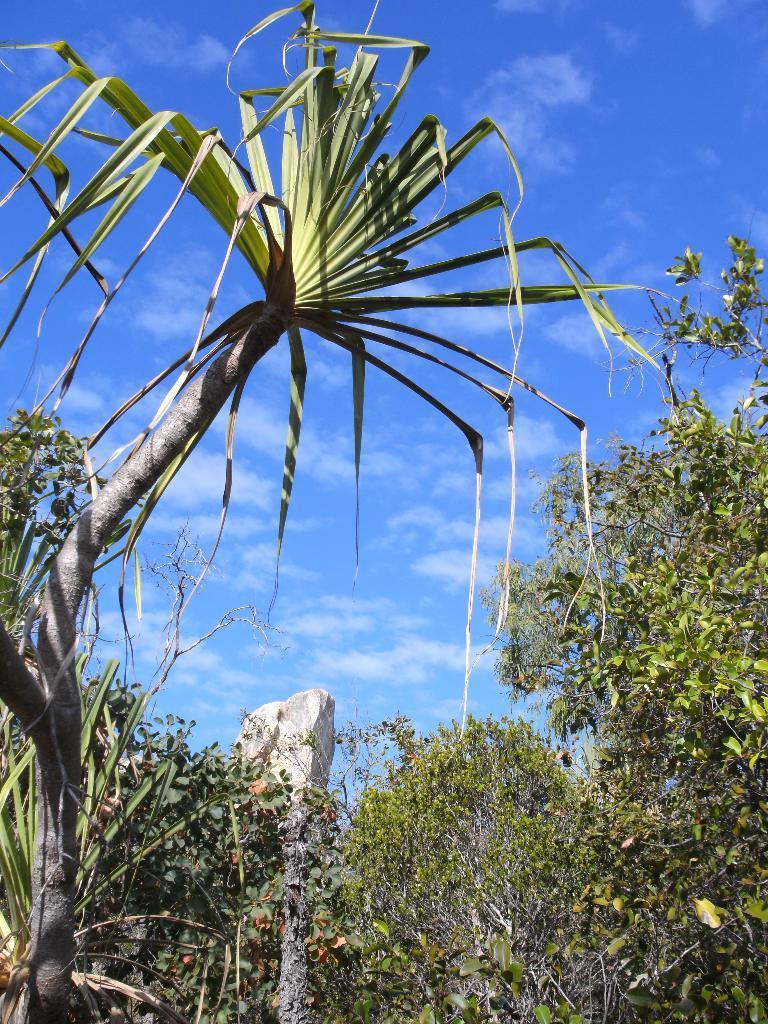In one or two sentences, can you explain what this image depicts? This picture is taken from the outside of the city. In this image, we can see some trees and plants. In the middle of the image, we can see a pillar. At the top, we can see a sky which is a bit cloudy. 